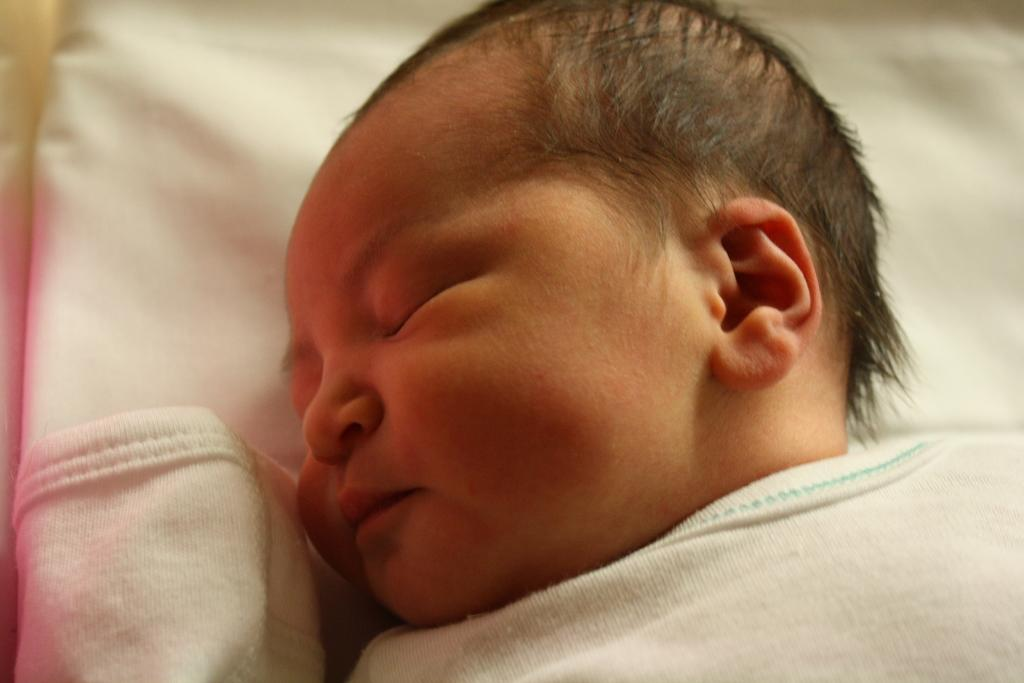What is the main subject of the image? There is a baby in the image. What is the baby laying on? The baby is laying on a white surface. What type of badge is the baby wearing in the image? There is no badge present in the image. How does the baby feel about the spring season in the image? The image does not provide any information about the baby's feelings or the spring season. 